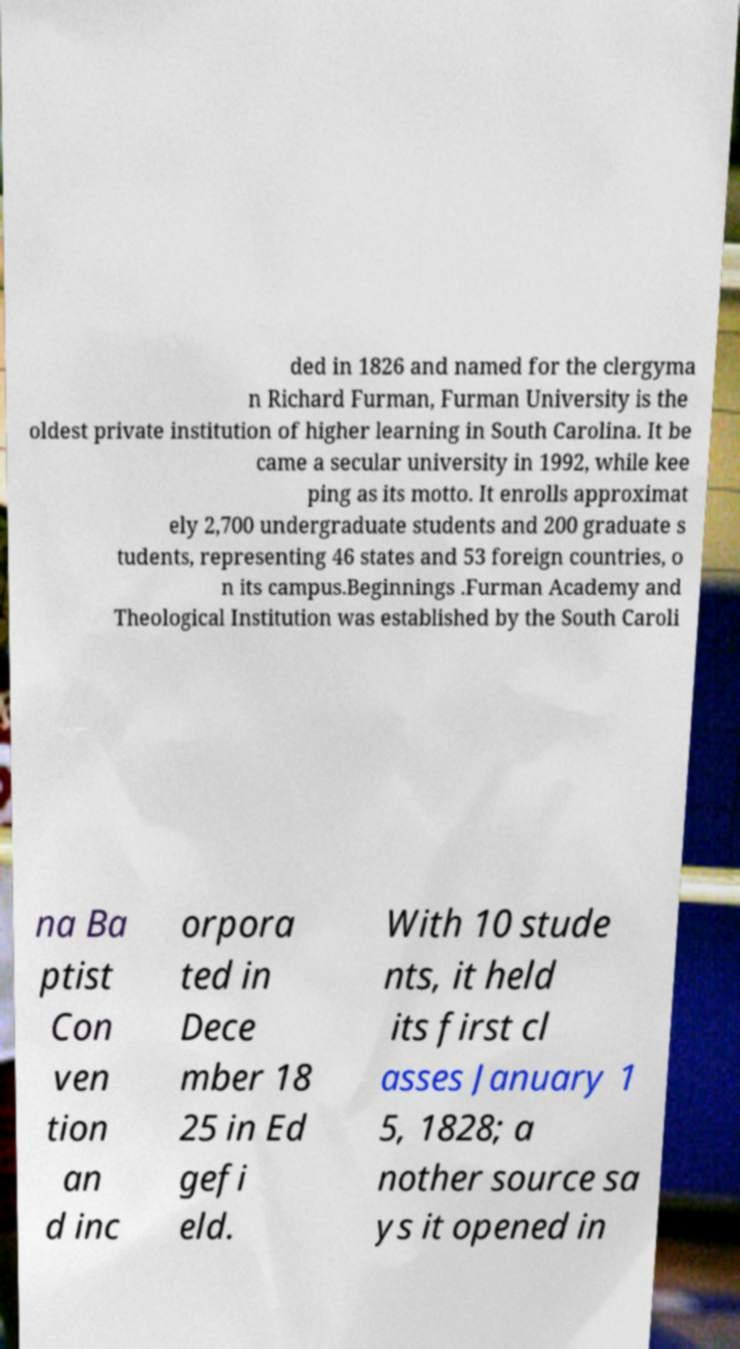Could you extract and type out the text from this image? ded in 1826 and named for the clergyma n Richard Furman, Furman University is the oldest private institution of higher learning in South Carolina. It be came a secular university in 1992, while kee ping as its motto. It enrolls approximat ely 2,700 undergraduate students and 200 graduate s tudents, representing 46 states and 53 foreign countries, o n its campus.Beginnings .Furman Academy and Theological Institution was established by the South Caroli na Ba ptist Con ven tion an d inc orpora ted in Dece mber 18 25 in Ed gefi eld. With 10 stude nts, it held its first cl asses January 1 5, 1828; a nother source sa ys it opened in 